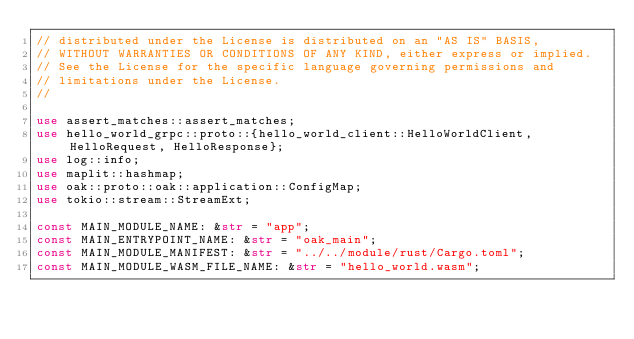Convert code to text. <code><loc_0><loc_0><loc_500><loc_500><_Rust_>// distributed under the License is distributed on an "AS IS" BASIS,
// WITHOUT WARRANTIES OR CONDITIONS OF ANY KIND, either express or implied.
// See the License for the specific language governing permissions and
// limitations under the License.
//

use assert_matches::assert_matches;
use hello_world_grpc::proto::{hello_world_client::HelloWorldClient, HelloRequest, HelloResponse};
use log::info;
use maplit::hashmap;
use oak::proto::oak::application::ConfigMap;
use tokio::stream::StreamExt;

const MAIN_MODULE_NAME: &str = "app";
const MAIN_ENTRYPOINT_NAME: &str = "oak_main";
const MAIN_MODULE_MANIFEST: &str = "../../module/rust/Cargo.toml";
const MAIN_MODULE_WASM_FILE_NAME: &str = "hello_world.wasm";
</code> 